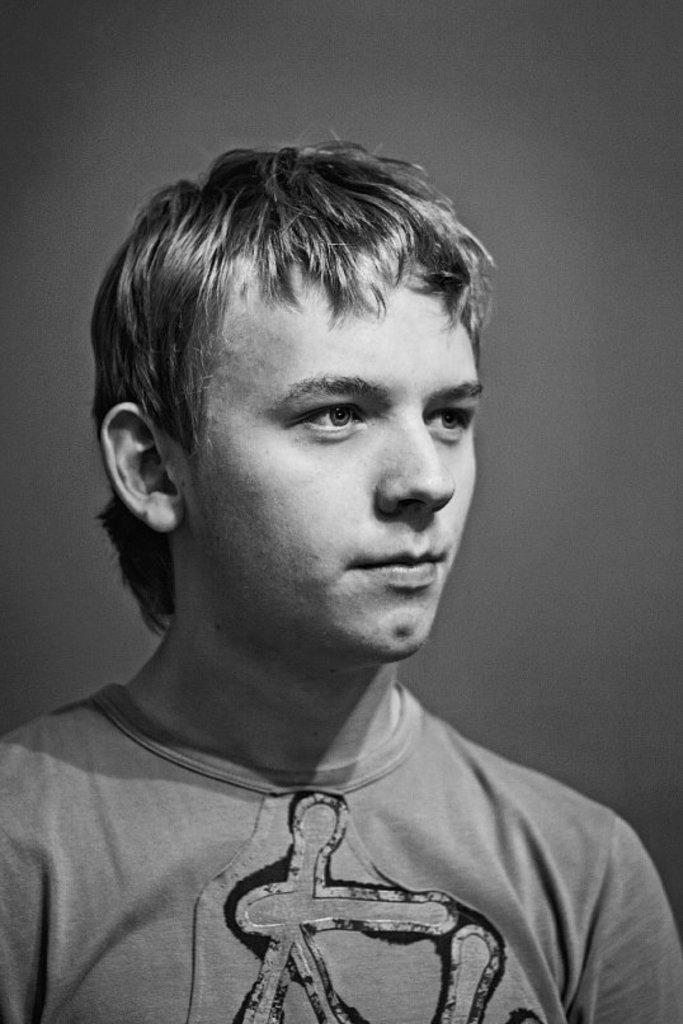Describe this image in one or two sentences. This is a black and white image. In this image we can see a man. 